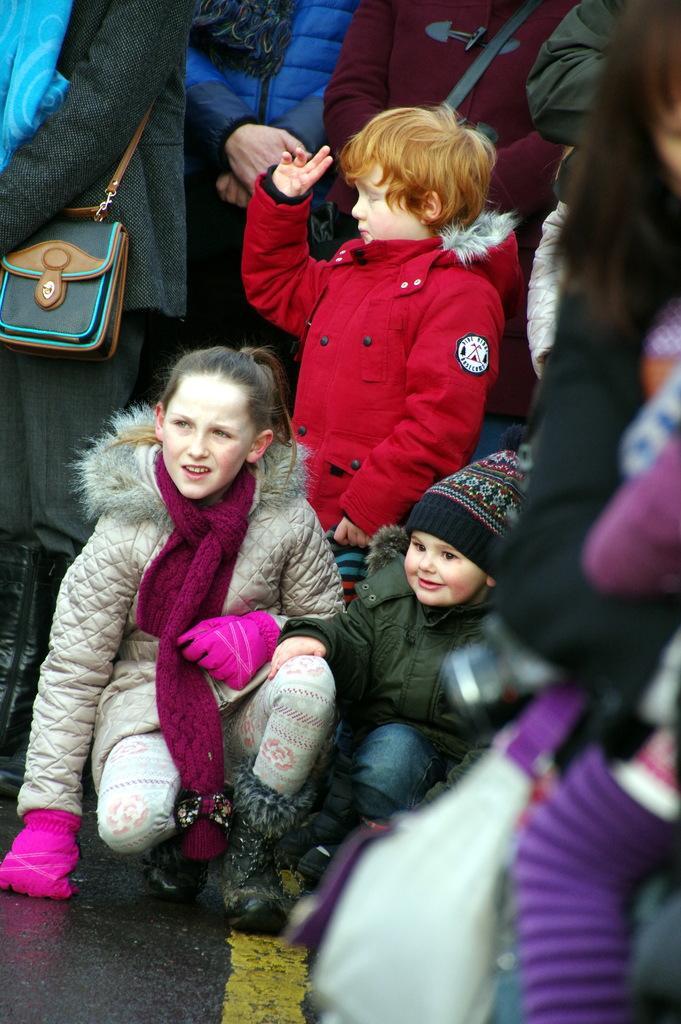Describe this image in one or two sentences. In this image there are a few people and children's sitting and standing on the road, a few are wearing their handbags. 